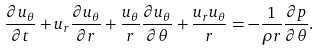<formula> <loc_0><loc_0><loc_500><loc_500>\frac { \partial u _ { \theta } } { \partial t } + u _ { r } \frac { \partial u _ { \theta } } { \partial r } + \frac { u _ { \theta } } { r } \frac { \partial u _ { \theta } } { \partial \theta } + \frac { u _ { r } u _ { \theta } } { r } = - \frac { 1 } { \rho r } \frac { \partial p } { \partial \theta } .</formula> 